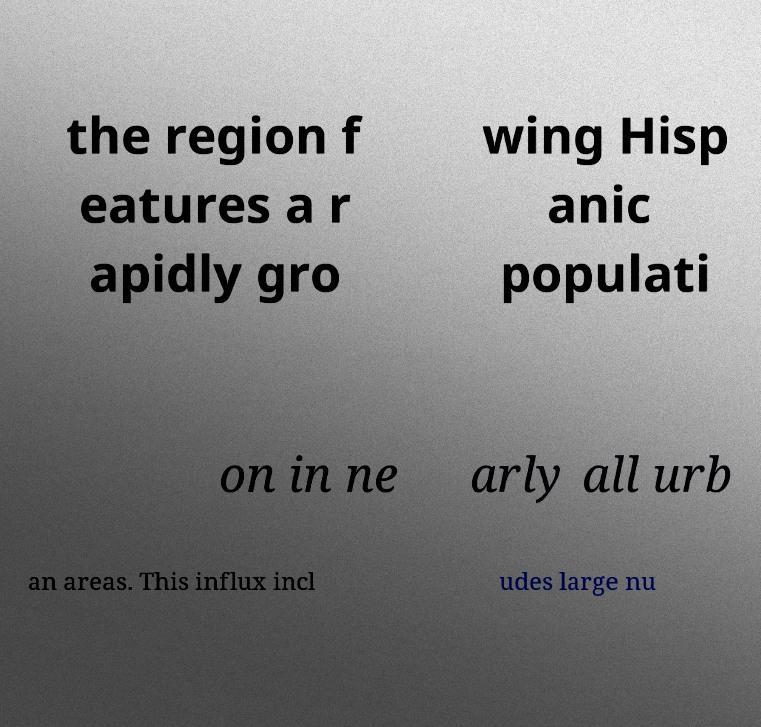Please identify and transcribe the text found in this image. the region f eatures a r apidly gro wing Hisp anic populati on in ne arly all urb an areas. This influx incl udes large nu 